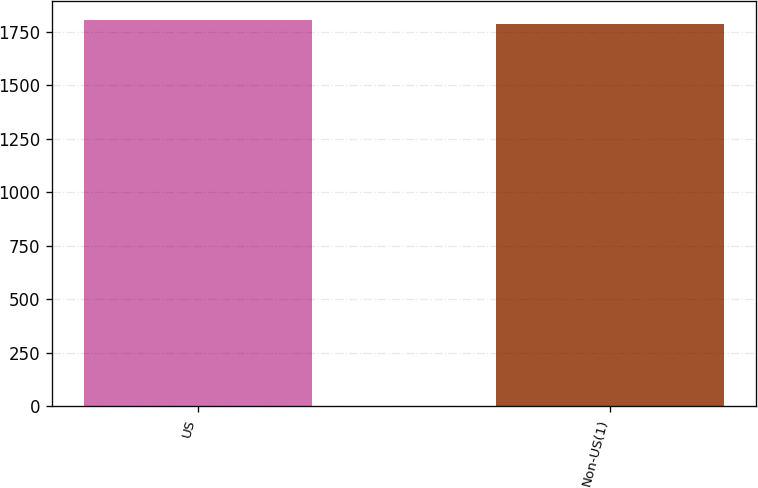<chart> <loc_0><loc_0><loc_500><loc_500><bar_chart><fcel>US<fcel>Non-US(1)<nl><fcel>1805<fcel>1786<nl></chart> 